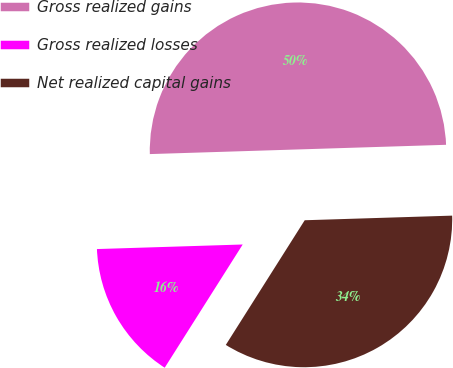<chart> <loc_0><loc_0><loc_500><loc_500><pie_chart><fcel>Gross realized gains<fcel>Gross realized losses<fcel>Net realized capital gains<nl><fcel>50.0%<fcel>15.52%<fcel>34.48%<nl></chart> 